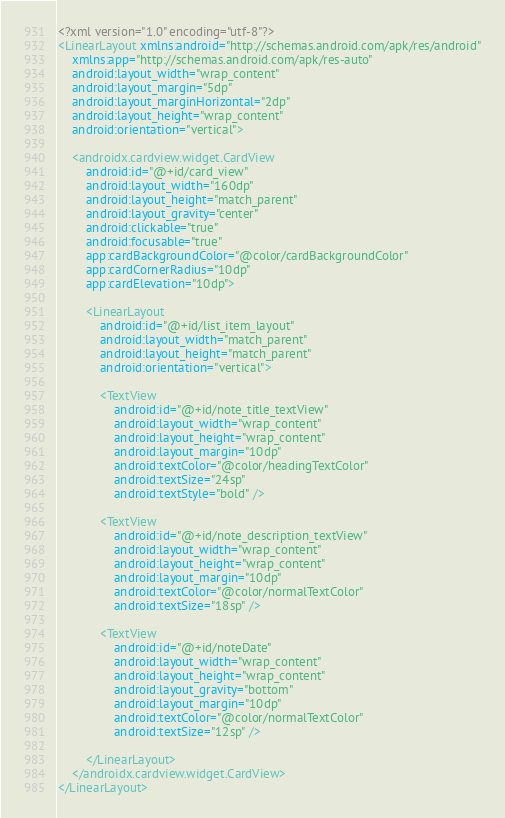Convert code to text. <code><loc_0><loc_0><loc_500><loc_500><_XML_><?xml version="1.0" encoding="utf-8"?>
<LinearLayout xmlns:android="http://schemas.android.com/apk/res/android"
    xmlns:app="http://schemas.android.com/apk/res-auto"
    android:layout_width="wrap_content"
    android:layout_margin="5dp"
    android:layout_marginHorizontal="2dp"
    android:layout_height="wrap_content"
    android:orientation="vertical">

    <androidx.cardview.widget.CardView
        android:id="@+id/card_view"
        android:layout_width="160dp"
        android:layout_height="match_parent"
        android:layout_gravity="center"
        android:clickable="true"
        android:focusable="true"
        app:cardBackgroundColor="@color/cardBackgroundColor"
        app:cardCornerRadius="10dp"
        app:cardElevation="10dp">

        <LinearLayout
            android:id="@+id/list_item_layout"
            android:layout_width="match_parent"
            android:layout_height="match_parent"
            android:orientation="vertical">

            <TextView
                android:id="@+id/note_title_textView"
                android:layout_width="wrap_content"
                android:layout_height="wrap_content"
                android:layout_margin="10dp"
                android:textColor="@color/headingTextColor"
                android:textSize="24sp"
                android:textStyle="bold" />

            <TextView
                android:id="@+id/note_description_textView"
                android:layout_width="wrap_content"
                android:layout_height="wrap_content"
                android:layout_margin="10dp"
                android:textColor="@color/normalTextColor"
                android:textSize="18sp" />

            <TextView
                android:id="@+id/noteDate"
                android:layout_width="wrap_content"
                android:layout_height="wrap_content"
                android:layout_gravity="bottom"
                android:layout_margin="10dp"
                android:textColor="@color/normalTextColor"
                android:textSize="12sp" />

        </LinearLayout>
    </androidx.cardview.widget.CardView>
</LinearLayout></code> 